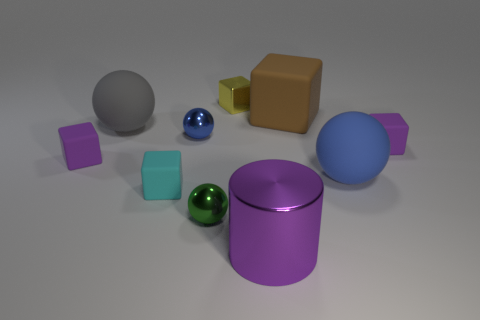Is there anything else that has the same shape as the big shiny object?
Keep it short and to the point. No. How many things are either small gray blocks or small metallic cubes?
Make the answer very short. 1. Do the matte object that is on the left side of the gray sphere and the big matte thing that is in front of the gray object have the same shape?
Keep it short and to the point. No. What number of purple things are in front of the tiny green sphere and behind the big metal cylinder?
Offer a terse response. 0. How many other objects are there of the same size as the shiny block?
Give a very brief answer. 5. There is a ball that is both in front of the blue metallic thing and left of the big cylinder; what material is it?
Give a very brief answer. Metal. Do the cylinder and the small metallic sphere to the left of the tiny green object have the same color?
Offer a terse response. No. The brown thing that is the same shape as the cyan matte object is what size?
Make the answer very short. Large. What shape is the big object that is right of the large purple cylinder and in front of the tiny blue metal object?
Ensure brevity in your answer.  Sphere. There is a blue rubber sphere; is it the same size as the brown block that is behind the gray matte ball?
Your answer should be compact. Yes. 